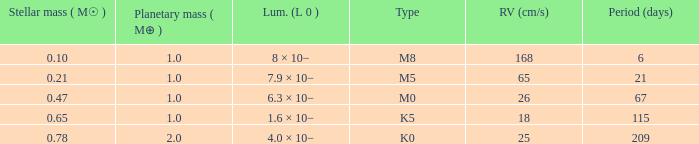What is the largest planetary mass possessing an rv (cm/s) of 65 and a period (days) under 21? None. 